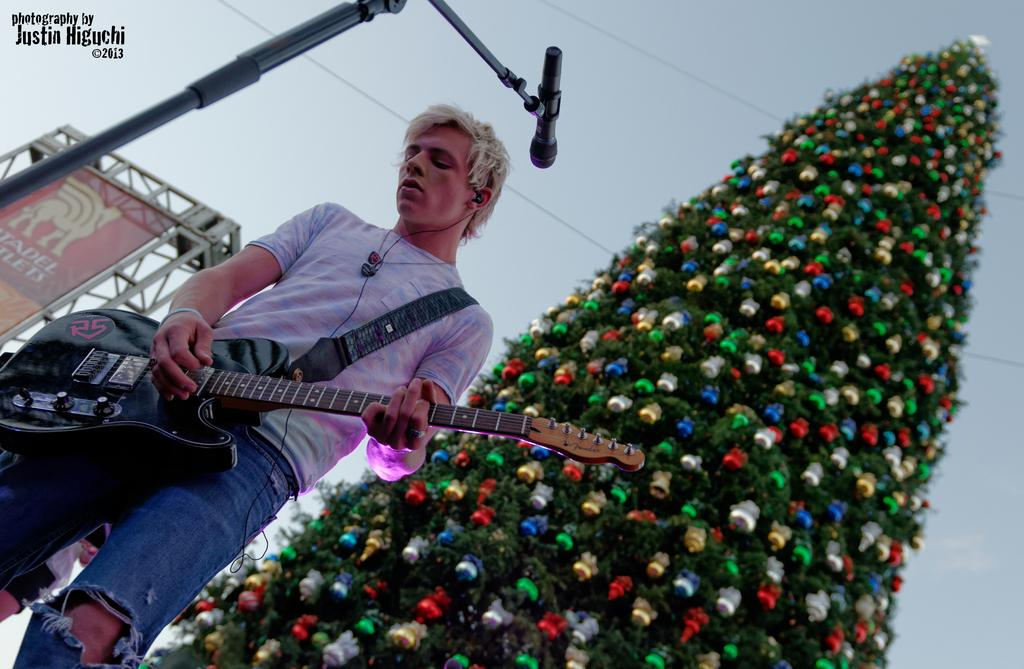What is the man in the image doing? The man is standing in front of a mic and holding a guitar. What object is the man standing in front of? The man is standing in front of a mic. What instrument is the man holding? The man is holding a guitar. What can be seen in the background of the image? There is a tree in the background of the image. How is the tree in the background decorated? The tree is decorated. What type of payment is the man receiving for his performance in the image? There is no indication of payment in the image; it only shows the man standing in front of a mic and holding a guitar. What emotion is the man expressing while playing the guitar in the image? The image does not show the man's emotions or expressions while playing the guitar. 